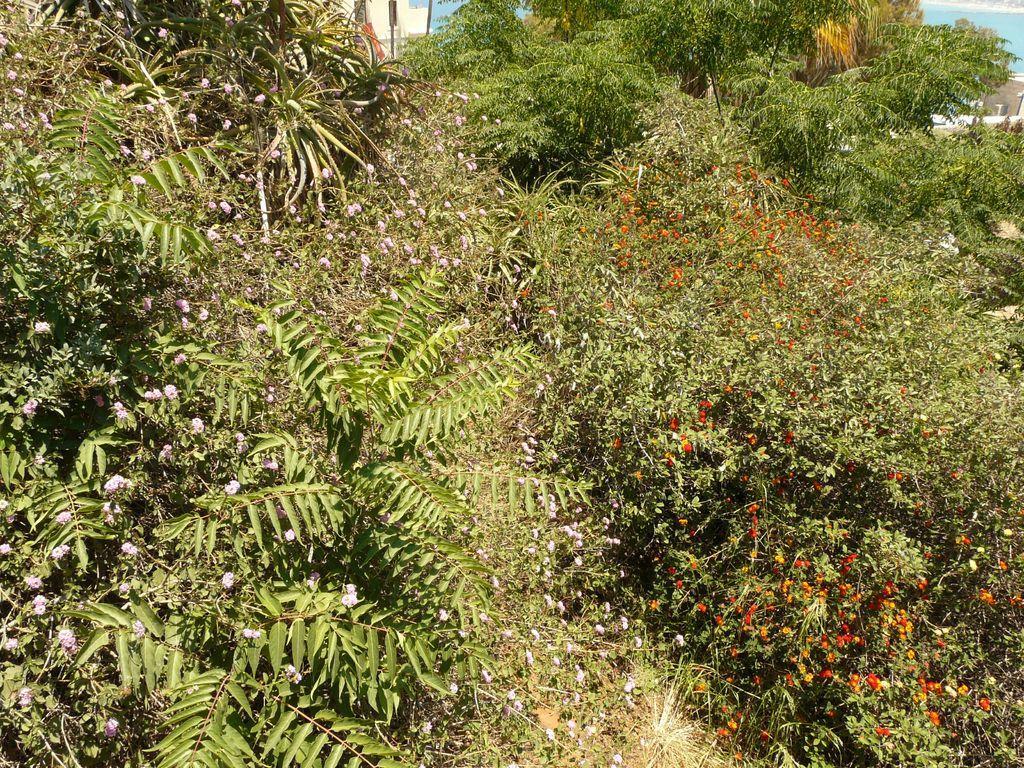Can you describe this image briefly? There is greenery and few small flowers in the foreground, it seems like water and a wall in the background area. 